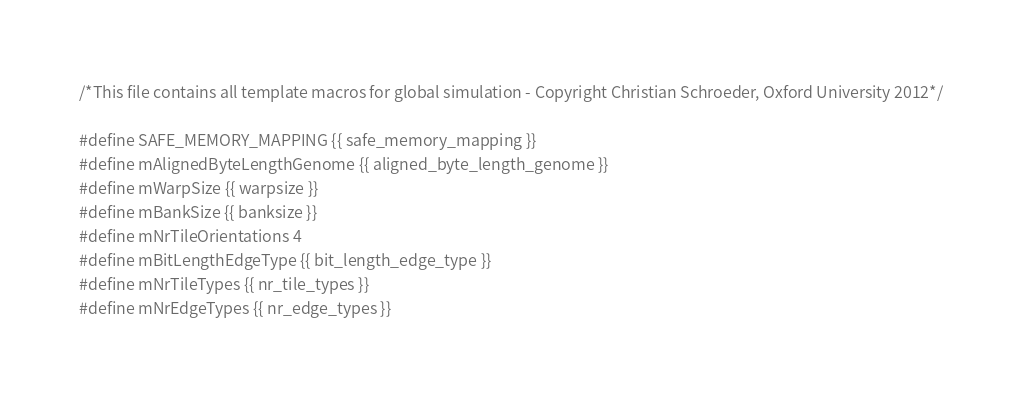<code> <loc_0><loc_0><loc_500><loc_500><_Cuda_>/*This file contains all template macros for global simulation - Copyright Christian Schroeder, Oxford University 2012*/

#define SAFE_MEMORY_MAPPING {{ safe_memory_mapping }}
#define mAlignedByteLengthGenome {{ aligned_byte_length_genome }}
#define mWarpSize {{ warpsize }}
#define mBankSize {{ banksize }}
#define mNrTileOrientations 4
#define mBitLengthEdgeType {{ bit_length_edge_type }}
#define mNrTileTypes {{ nr_tile_types }}
#define mNrEdgeTypes {{ nr_edge_types }}
</code> 